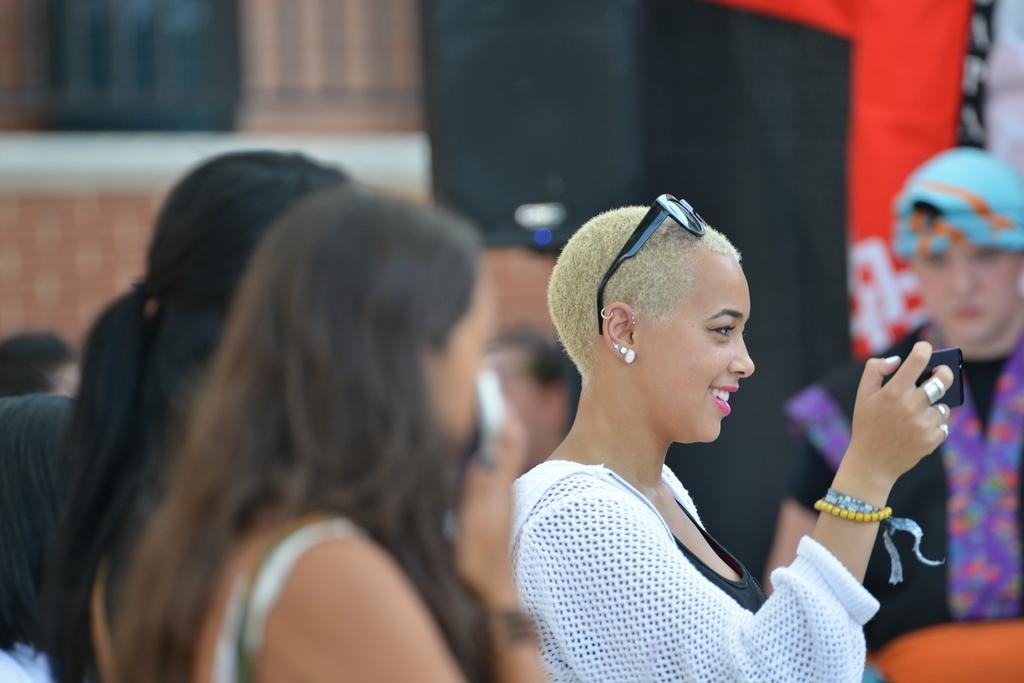Please provide a concise description of this image. In this image we can able to see a lady holding a phone and she is having glasses on her head and she is wearing earrings she is wearing hand bands and she is wearing rings and there is a person who is wearing blue color hat there are two ladies here. 